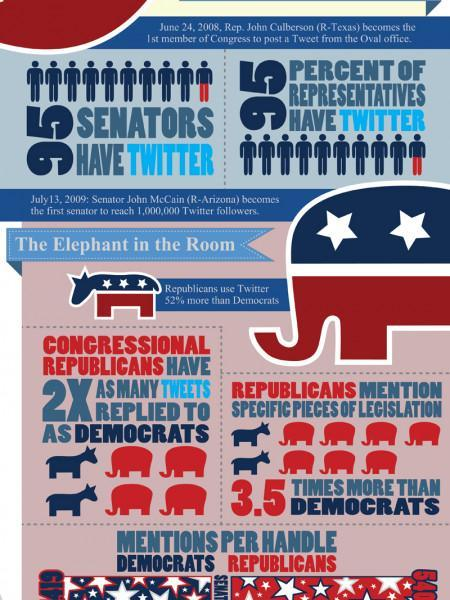What percentage of US Senators do not have Twitter account?
Answer the question with a short phrase. 5 How much more Republicans add tweets regarding Legislation when comparing with Democrats? 3.5 times What percentage of US representatives do not have Twitter account? 5 